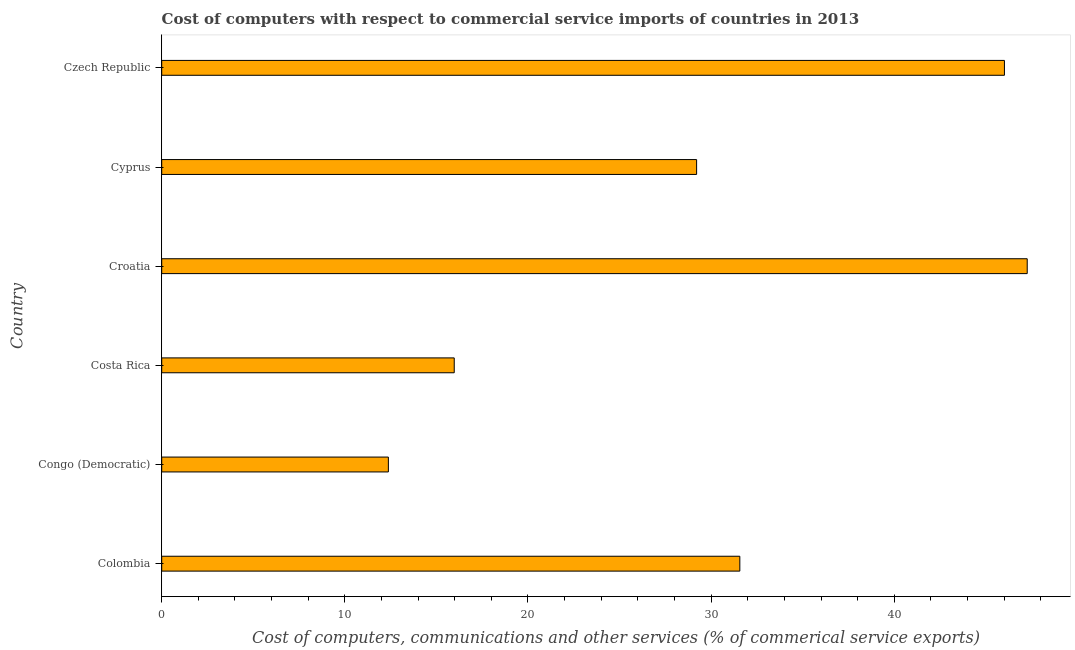What is the title of the graph?
Provide a succinct answer. Cost of computers with respect to commercial service imports of countries in 2013. What is the label or title of the X-axis?
Ensure brevity in your answer.  Cost of computers, communications and other services (% of commerical service exports). What is the cost of communications in Croatia?
Make the answer very short. 47.26. Across all countries, what is the maximum cost of communications?
Ensure brevity in your answer.  47.26. Across all countries, what is the minimum  computer and other services?
Make the answer very short. 12.38. In which country was the  computer and other services maximum?
Make the answer very short. Croatia. In which country was the  computer and other services minimum?
Offer a terse response. Congo (Democratic). What is the sum of the  computer and other services?
Your answer should be very brief. 182.4. What is the difference between the cost of communications in Costa Rica and Croatia?
Your answer should be compact. -31.29. What is the average  computer and other services per country?
Give a very brief answer. 30.4. What is the median cost of communications?
Provide a short and direct response. 30.39. What is the ratio of the  computer and other services in Colombia to that in Cyprus?
Your response must be concise. 1.08. What is the difference between the highest and the second highest  computer and other services?
Give a very brief answer. 1.24. What is the difference between the highest and the lowest  computer and other services?
Keep it short and to the point. 34.88. In how many countries, is the cost of communications greater than the average cost of communications taken over all countries?
Offer a terse response. 3. Are all the bars in the graph horizontal?
Make the answer very short. Yes. Are the values on the major ticks of X-axis written in scientific E-notation?
Offer a very short reply. No. What is the Cost of computers, communications and other services (% of commerical service exports) in Colombia?
Provide a succinct answer. 31.57. What is the Cost of computers, communications and other services (% of commerical service exports) in Congo (Democratic)?
Provide a succinct answer. 12.38. What is the Cost of computers, communications and other services (% of commerical service exports) in Costa Rica?
Offer a very short reply. 15.97. What is the Cost of computers, communications and other services (% of commerical service exports) in Croatia?
Your answer should be very brief. 47.26. What is the Cost of computers, communications and other services (% of commerical service exports) of Cyprus?
Your answer should be very brief. 29.21. What is the Cost of computers, communications and other services (% of commerical service exports) of Czech Republic?
Provide a succinct answer. 46.02. What is the difference between the Cost of computers, communications and other services (% of commerical service exports) in Colombia and Congo (Democratic)?
Your answer should be compact. 19.19. What is the difference between the Cost of computers, communications and other services (% of commerical service exports) in Colombia and Costa Rica?
Provide a short and direct response. 15.59. What is the difference between the Cost of computers, communications and other services (% of commerical service exports) in Colombia and Croatia?
Ensure brevity in your answer.  -15.69. What is the difference between the Cost of computers, communications and other services (% of commerical service exports) in Colombia and Cyprus?
Your answer should be compact. 2.36. What is the difference between the Cost of computers, communications and other services (% of commerical service exports) in Colombia and Czech Republic?
Give a very brief answer. -14.45. What is the difference between the Cost of computers, communications and other services (% of commerical service exports) in Congo (Democratic) and Costa Rica?
Give a very brief answer. -3.6. What is the difference between the Cost of computers, communications and other services (% of commerical service exports) in Congo (Democratic) and Croatia?
Your response must be concise. -34.88. What is the difference between the Cost of computers, communications and other services (% of commerical service exports) in Congo (Democratic) and Cyprus?
Offer a very short reply. -16.83. What is the difference between the Cost of computers, communications and other services (% of commerical service exports) in Congo (Democratic) and Czech Republic?
Your response must be concise. -33.64. What is the difference between the Cost of computers, communications and other services (% of commerical service exports) in Costa Rica and Croatia?
Your answer should be compact. -31.29. What is the difference between the Cost of computers, communications and other services (% of commerical service exports) in Costa Rica and Cyprus?
Your response must be concise. -13.23. What is the difference between the Cost of computers, communications and other services (% of commerical service exports) in Costa Rica and Czech Republic?
Provide a succinct answer. -30.04. What is the difference between the Cost of computers, communications and other services (% of commerical service exports) in Croatia and Cyprus?
Your answer should be very brief. 18.05. What is the difference between the Cost of computers, communications and other services (% of commerical service exports) in Croatia and Czech Republic?
Make the answer very short. 1.24. What is the difference between the Cost of computers, communications and other services (% of commerical service exports) in Cyprus and Czech Republic?
Your answer should be very brief. -16.81. What is the ratio of the Cost of computers, communications and other services (% of commerical service exports) in Colombia to that in Congo (Democratic)?
Provide a succinct answer. 2.55. What is the ratio of the Cost of computers, communications and other services (% of commerical service exports) in Colombia to that in Costa Rica?
Offer a very short reply. 1.98. What is the ratio of the Cost of computers, communications and other services (% of commerical service exports) in Colombia to that in Croatia?
Keep it short and to the point. 0.67. What is the ratio of the Cost of computers, communications and other services (% of commerical service exports) in Colombia to that in Cyprus?
Keep it short and to the point. 1.08. What is the ratio of the Cost of computers, communications and other services (% of commerical service exports) in Colombia to that in Czech Republic?
Offer a terse response. 0.69. What is the ratio of the Cost of computers, communications and other services (% of commerical service exports) in Congo (Democratic) to that in Costa Rica?
Make the answer very short. 0.78. What is the ratio of the Cost of computers, communications and other services (% of commerical service exports) in Congo (Democratic) to that in Croatia?
Offer a very short reply. 0.26. What is the ratio of the Cost of computers, communications and other services (% of commerical service exports) in Congo (Democratic) to that in Cyprus?
Provide a short and direct response. 0.42. What is the ratio of the Cost of computers, communications and other services (% of commerical service exports) in Congo (Democratic) to that in Czech Republic?
Your answer should be very brief. 0.27. What is the ratio of the Cost of computers, communications and other services (% of commerical service exports) in Costa Rica to that in Croatia?
Keep it short and to the point. 0.34. What is the ratio of the Cost of computers, communications and other services (% of commerical service exports) in Costa Rica to that in Cyprus?
Give a very brief answer. 0.55. What is the ratio of the Cost of computers, communications and other services (% of commerical service exports) in Costa Rica to that in Czech Republic?
Make the answer very short. 0.35. What is the ratio of the Cost of computers, communications and other services (% of commerical service exports) in Croatia to that in Cyprus?
Provide a succinct answer. 1.62. What is the ratio of the Cost of computers, communications and other services (% of commerical service exports) in Cyprus to that in Czech Republic?
Ensure brevity in your answer.  0.64. 